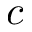Convert formula to latex. <formula><loc_0><loc_0><loc_500><loc_500>c</formula> 